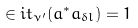<formula> <loc_0><loc_0><loc_500><loc_500>\in i t _ { \nu ^ { \prime } } ( a ^ { * } a _ { \delta l } ) = 1</formula> 